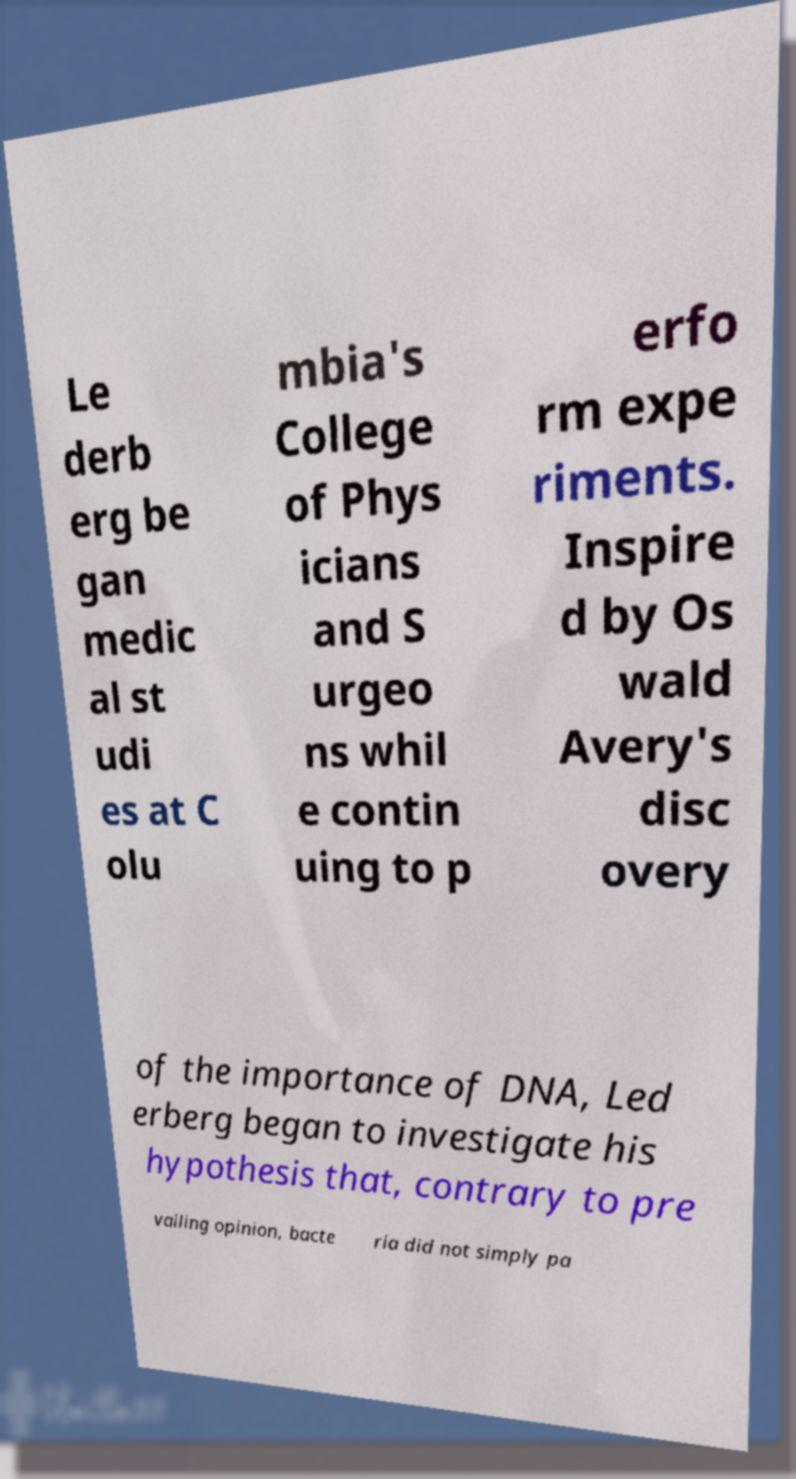For documentation purposes, I need the text within this image transcribed. Could you provide that? Le derb erg be gan medic al st udi es at C olu mbia's College of Phys icians and S urgeo ns whil e contin uing to p erfo rm expe riments. Inspire d by Os wald Avery's disc overy of the importance of DNA, Led erberg began to investigate his hypothesis that, contrary to pre vailing opinion, bacte ria did not simply pa 